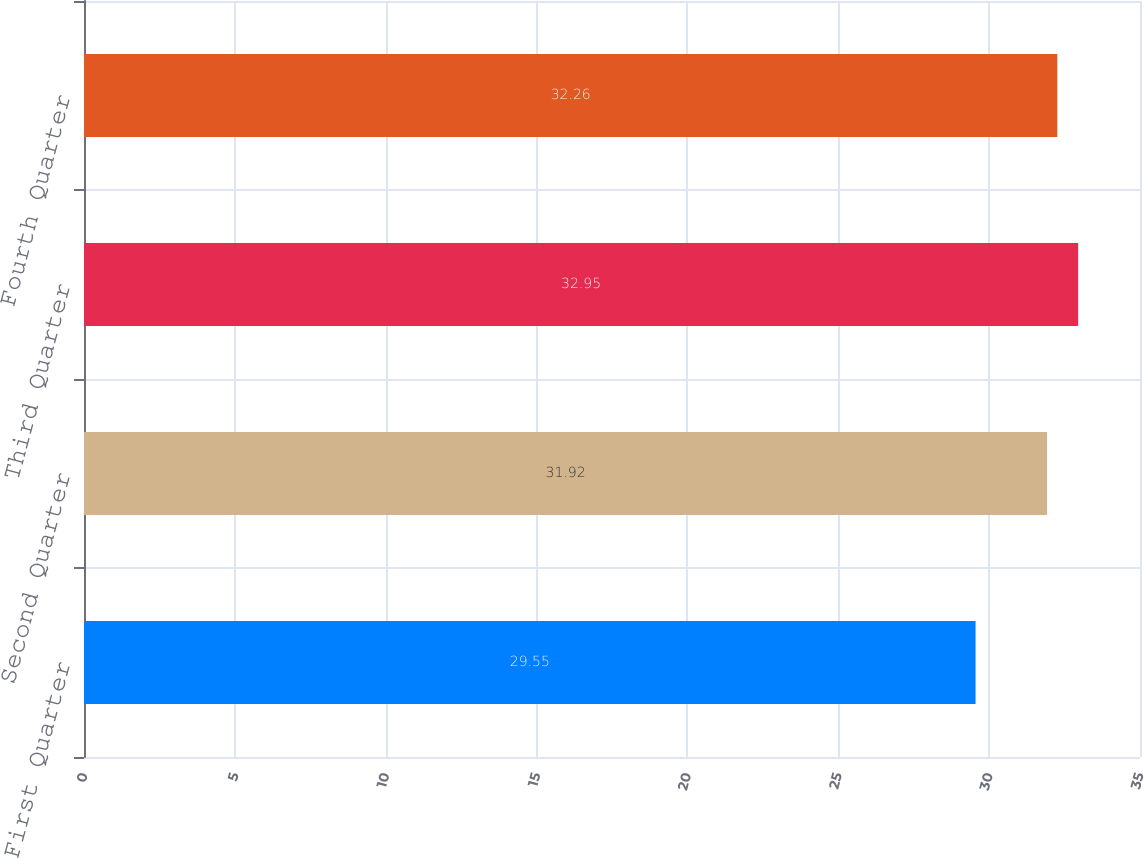<chart> <loc_0><loc_0><loc_500><loc_500><bar_chart><fcel>First Quarter<fcel>Second Quarter<fcel>Third Quarter<fcel>Fourth Quarter<nl><fcel>29.55<fcel>31.92<fcel>32.95<fcel>32.26<nl></chart> 